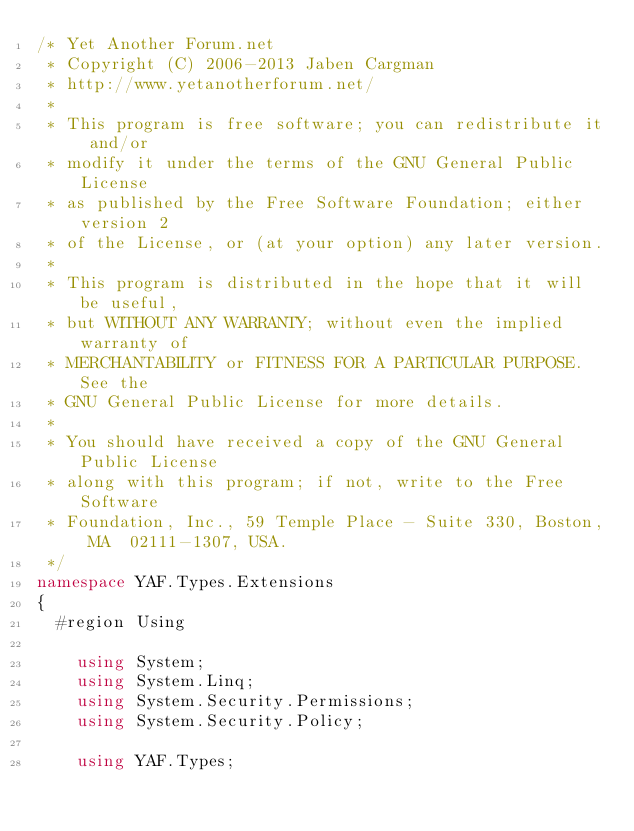<code> <loc_0><loc_0><loc_500><loc_500><_C#_>/* Yet Another Forum.net
 * Copyright (C) 2006-2013 Jaben Cargman
 * http://www.yetanotherforum.net/
 * 
 * This program is free software; you can redistribute it and/or
 * modify it under the terms of the GNU General Public License
 * as published by the Free Software Foundation; either version 2
 * of the License, or (at your option) any later version.
 * 
 * This program is distributed in the hope that it will be useful,
 * but WITHOUT ANY WARRANTY; without even the implied warranty of
 * MERCHANTABILITY or FITNESS FOR A PARTICULAR PURPOSE.  See the
 * GNU General Public License for more details.
 * 
 * You should have received a copy of the GNU General Public License
 * along with this program; if not, write to the Free Software
 * Foundation, Inc., 59 Temple Place - Suite 330, Boston, MA  02111-1307, USA.
 */
namespace YAF.Types.Extensions
{
  #region Using

    using System;
    using System.Linq;
    using System.Security.Permissions;
    using System.Security.Policy;

    using YAF.Types;
</code> 